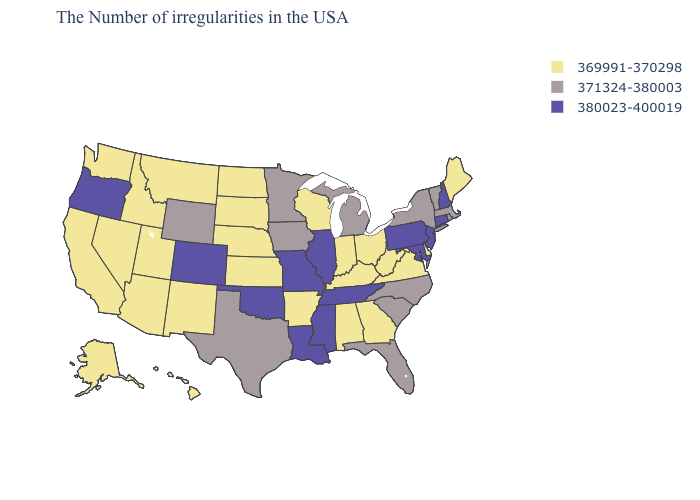What is the value of Alaska?
Quick response, please. 369991-370298. What is the value of Hawaii?
Short answer required. 369991-370298. Is the legend a continuous bar?
Write a very short answer. No. What is the value of Texas?
Keep it brief. 371324-380003. Does Pennsylvania have the highest value in the Northeast?
Quick response, please. Yes. What is the highest value in the USA?
Write a very short answer. 380023-400019. Does the map have missing data?
Be succinct. No. What is the value of New Hampshire?
Quick response, please. 380023-400019. Name the states that have a value in the range 380023-400019?
Keep it brief. New Hampshire, Connecticut, New Jersey, Maryland, Pennsylvania, Tennessee, Illinois, Mississippi, Louisiana, Missouri, Oklahoma, Colorado, Oregon. Which states have the lowest value in the Northeast?
Write a very short answer. Maine. Does Iowa have the lowest value in the MidWest?
Answer briefly. No. Among the states that border Louisiana , does Texas have the highest value?
Write a very short answer. No. Does Illinois have the lowest value in the USA?
Concise answer only. No. 